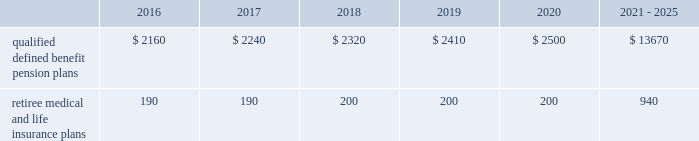Contributions and expected benefit payments the funding of our qualified defined benefit pension plans is determined in accordance with erisa , as amended by the ppa , and in a manner consistent with cas and internal revenue code rules .
In 2015 , we made $ 5 million in contributions to our new sikorsky bargained qualified defined benefit pension plan and we plan to make approximately $ 25 million in contributions to this plan in 2016 .
The table presents estimated future benefit payments , which reflect expected future employee service , as of december 31 , 2015 ( in millions ) : .
Defined contribution plans we maintain a number of defined contribution plans , most with 401 ( k ) features , that cover substantially all of our employees .
Under the provisions of our 401 ( k ) plans , we match most employees 2019 eligible contributions at rates specified in the plan documents .
Our contributions were $ 393 million in 2015 , $ 385 million in 2014 and $ 383 million in 2013 , the majority of which were funded in our common stock .
Our defined contribution plans held approximately 40.0 million and 41.7 million shares of our common stock as of december 31 , 2015 and 2014 .
Note 12 2013 stockholders 2019 equity at december 31 , 2015 and 2014 , our authorized capital was composed of 1.5 billion shares of common stock and 50 million shares of series preferred stock .
Of the 305 million shares of common stock issued and outstanding as of december 31 , 2015 , 303 million shares were considered outstanding for balance sheet presentation purposes ; the remaining shares were held in a separate trust .
Of the 316 million shares of common stock issued and outstanding as of december 31 , 2014 , 314 million shares were considered outstanding for balance sheet presentation purposes ; the remaining shares were held in a separate trust .
No shares of preferred stock were issued and outstanding at december 31 , 2015 or 2014 .
Repurchases of common stock during 2015 , we repurchased 15.2 million shares of our common stock for $ 3.1 billion .
During 2014 and 2013 , we paid $ 1.9 billion and $ 1.8 billion to repurchase 11.5 million and 16.2 million shares of our common stock .
On september 24 , 2015 , our board of directors approved a $ 3.0 billion increase to our share repurchase program .
Inclusive of this increase , the total remaining authorization for future common share repurchases under our program was $ 3.6 billion as of december 31 , 2015 .
As we repurchase our common shares , we reduce common stock for the $ 1 of par value of the shares repurchased , with the excess purchase price over par value recorded as a reduction of additional paid-in capital .
Due to the volume of repurchases made under our share repurchase program , additional paid-in capital was reduced to zero , with the remainder of the excess purchase price over par value of $ 2.4 billion and $ 1.1 billion recorded as a reduction of retained earnings in 2015 and 2014 .
We paid dividends totaling $ 1.9 billion ( $ 6.15 per share ) in 2015 , $ 1.8 billion ( $ 5.49 per share ) in 2014 and $ 1.5 billion ( $ 4.78 per share ) in 2013 .
We have increased our quarterly dividend rate in each of the last three years , including a 10% ( 10 % ) increase in the quarterly dividend rate in the fourth quarter of 2015 .
We declared quarterly dividends of $ 1.50 per share during each of the first three quarters of 2015 and $ 1.65 per share during the fourth quarter of 2015 ; $ 1.33 per share during each of the first three quarters of 2014 and $ 1.50 per share during the fourth quarter of 2014 ; and $ 1.15 per share during each of the first three quarters of 2013 and $ 1.33 per share during the fourth quarter of 2013. .
What is the change in millions of qualified defined benefit pension plans expected to be paid out between 2016 to 2017? 
Computations: (2240 - 2160)
Answer: 80.0. 